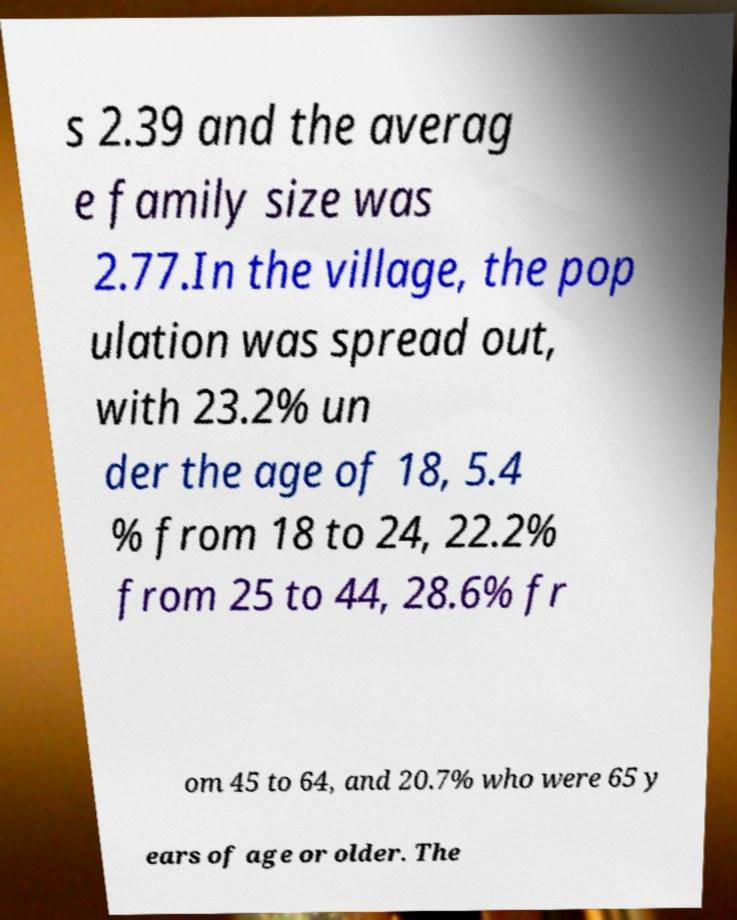Could you extract and type out the text from this image? s 2.39 and the averag e family size was 2.77.In the village, the pop ulation was spread out, with 23.2% un der the age of 18, 5.4 % from 18 to 24, 22.2% from 25 to 44, 28.6% fr om 45 to 64, and 20.7% who were 65 y ears of age or older. The 